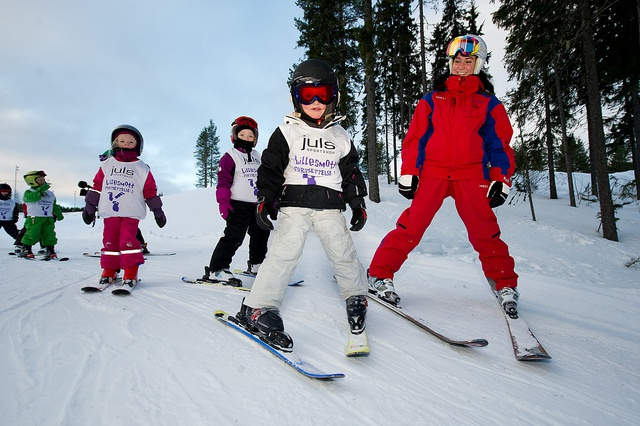Describe the objects in this image and their specific colors. I can see people in lightgray, brown, black, and navy tones, people in lightgray, black, darkgray, and gray tones, people in lightgray, maroon, darkgray, black, and brown tones, people in lightgray, black, darkgray, and purple tones, and people in lightgray, black, darkgreen, darkgray, and gray tones in this image. 